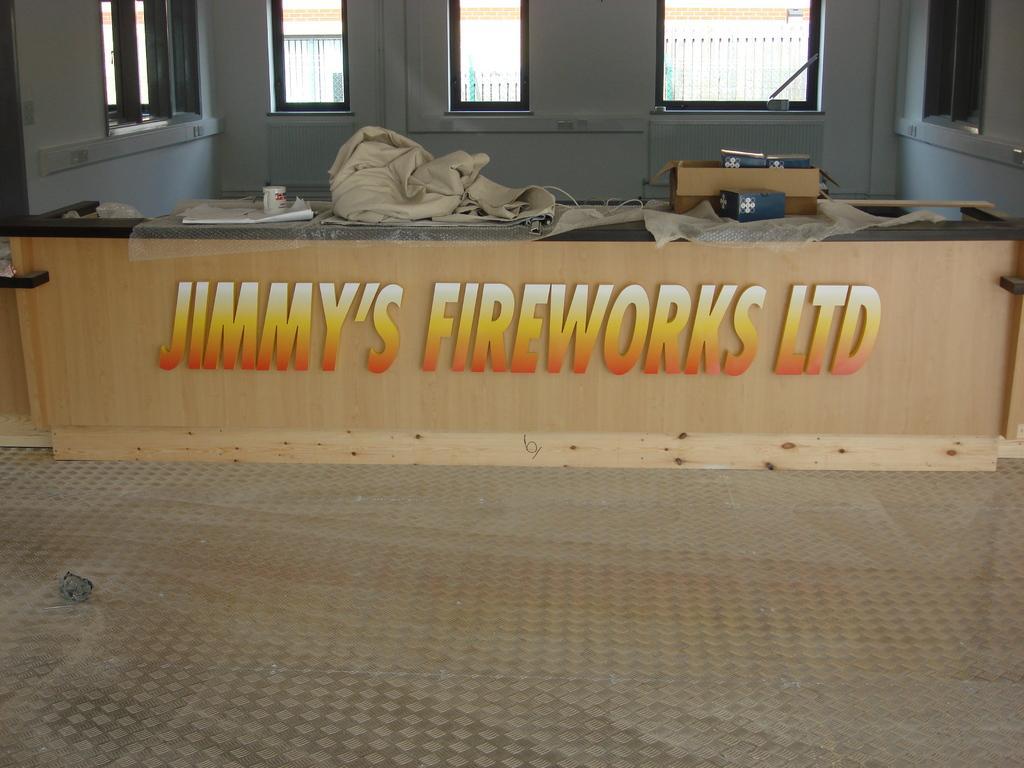Describe this image in one or two sentences. This is the picture of a inner view of a building and we can see a wooden wall with some text and there are some objects and in the background we can see the wall with windows. 